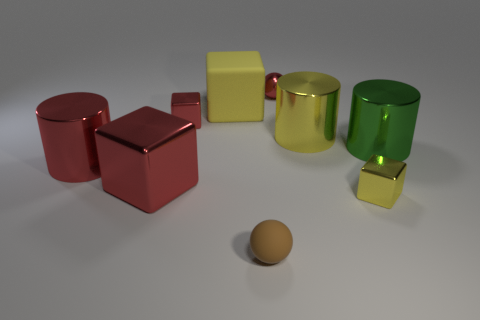Subtract all gray spheres. How many red blocks are left? 2 Add 1 red metal cylinders. How many objects exist? 10 Subtract all tiny red shiny blocks. How many blocks are left? 3 Subtract all purple blocks. Subtract all purple balls. How many blocks are left? 4 Add 7 yellow blocks. How many yellow blocks exist? 9 Subtract 0 gray cubes. How many objects are left? 9 Subtract all spheres. How many objects are left? 7 Subtract all big yellow shiny balls. Subtract all yellow matte blocks. How many objects are left? 8 Add 8 large rubber objects. How many large rubber objects are left? 9 